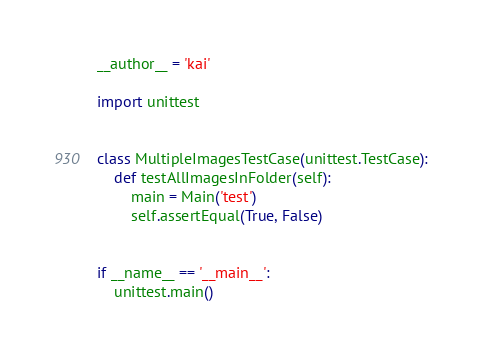<code> <loc_0><loc_0><loc_500><loc_500><_Python_>__author__ = 'kai'

import unittest


class MultipleImagesTestCase(unittest.TestCase):
    def testAllImagesInFolder(self):
        main = Main('test')
        self.assertEqual(True, False)


if __name__ == '__main__':
    unittest.main()
</code> 